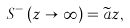<formula> <loc_0><loc_0><loc_500><loc_500>S ^ { - } \left ( z \rightarrow \infty \right ) = \widetilde { a } z ,</formula> 